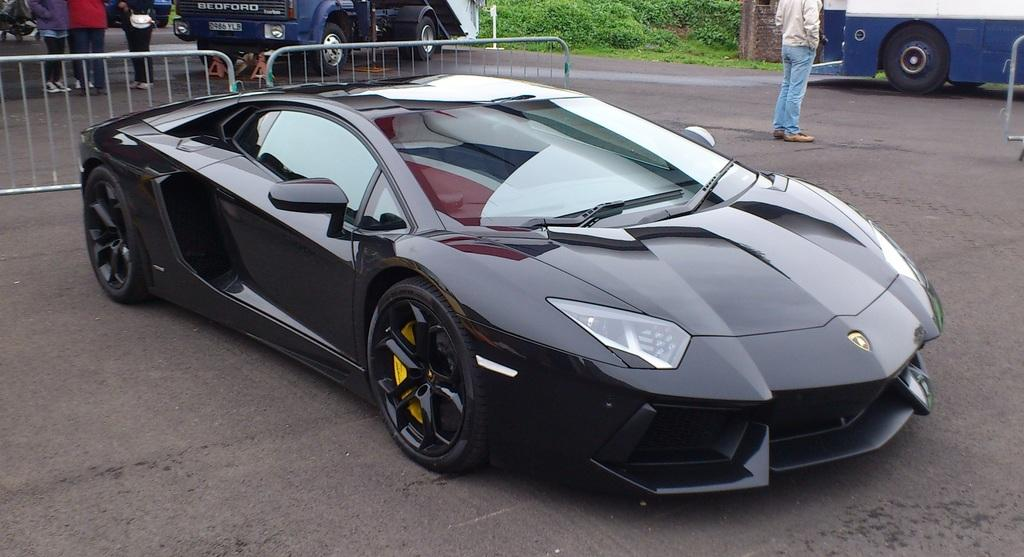What can be seen on the road in the image? There are vehicles on the road in the image. What else is present in the image besides the vehicles? There are barriers, a group of people standing, and plants in the image. What advice is the turkey giving to the group of people in the image? There is no turkey present in the image, and therefore no advice can be given. 